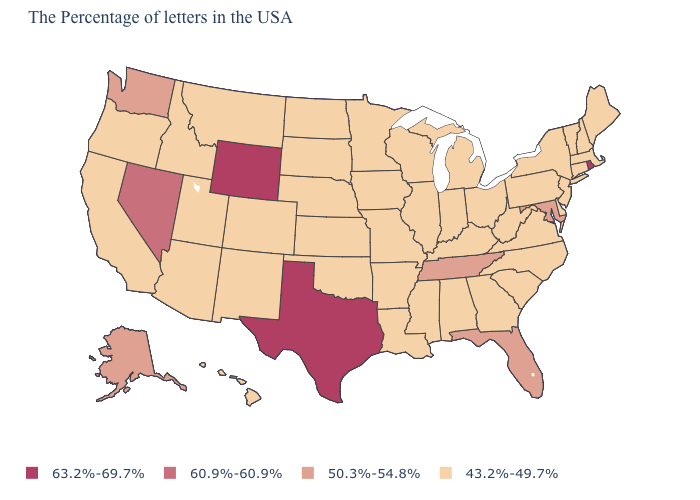What is the value of North Dakota?
Concise answer only. 43.2%-49.7%. Does the first symbol in the legend represent the smallest category?
Give a very brief answer. No. What is the value of Virginia?
Quick response, please. 43.2%-49.7%. Is the legend a continuous bar?
Answer briefly. No. How many symbols are there in the legend?
Be succinct. 4. Among the states that border Florida , which have the highest value?
Short answer required. Georgia, Alabama. What is the value of Louisiana?
Concise answer only. 43.2%-49.7%. Name the states that have a value in the range 60.9%-60.9%?
Write a very short answer. Nevada. What is the value of Wyoming?
Short answer required. 63.2%-69.7%. What is the lowest value in the MidWest?
Concise answer only. 43.2%-49.7%. Does Florida have the lowest value in the South?
Keep it brief. No. Name the states that have a value in the range 50.3%-54.8%?
Keep it brief. Maryland, Florida, Tennessee, Washington, Alaska. Does Wyoming have the highest value in the West?
Be succinct. Yes. Which states hav the highest value in the South?
Short answer required. Texas. Name the states that have a value in the range 60.9%-60.9%?
Answer briefly. Nevada. 